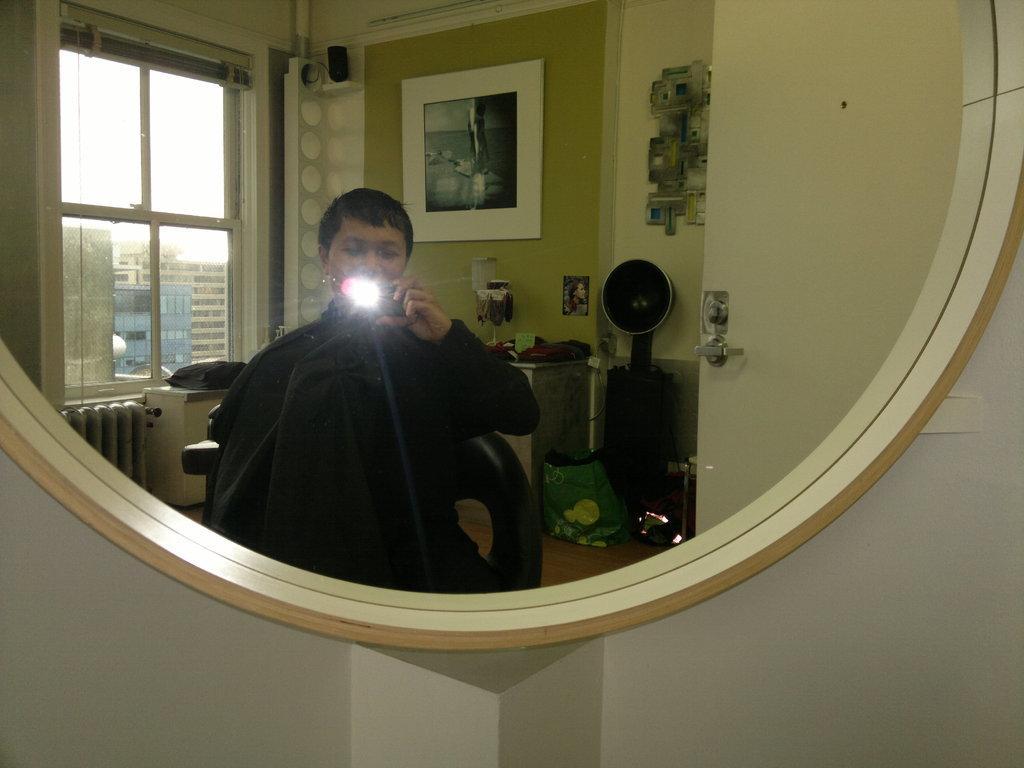In one or two sentences, can you explain what this image depicts? In this image I can see the wall and a mirror attached to the wall. In the mirror I can see the reflection of a person wearing black colored dress is sitting on a chair, the wall, a door, a photo frame attached to the wall, few other objects and the window through which I can see few buildings and the sky. 